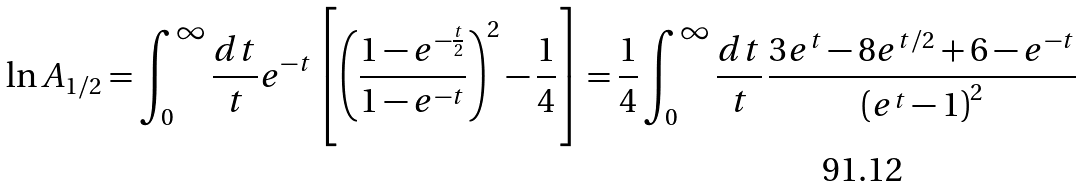Convert formula to latex. <formula><loc_0><loc_0><loc_500><loc_500>\ln A _ { 1 / 2 } = \int _ { 0 } ^ { \infty } \frac { d t } { t } e ^ { - t } \left [ \left ( \frac { 1 - e ^ { - \frac { t } { 2 } } } { 1 - e ^ { - t } } \right ) ^ { 2 } - \frac { 1 } { 4 } \right ] = \frac { 1 } { 4 } \int _ { 0 } ^ { \infty } \frac { d t } { t } \, \frac { 3 e ^ { t } - 8 e ^ { t / 2 } + 6 - e ^ { - t } } { \left ( e ^ { t } - 1 \right ) ^ { 2 } }</formula> 